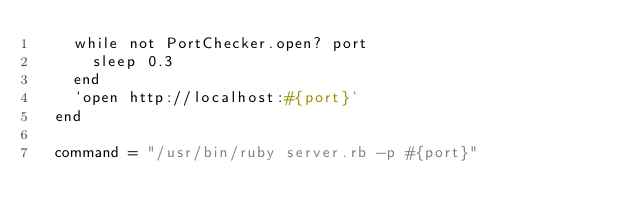Convert code to text. <code><loc_0><loc_0><loc_500><loc_500><_Ruby_>    while not PortChecker.open? port
      sleep 0.3
    end
    `open http://localhost:#{port}`
  end

  command = "/usr/bin/ruby server.rb -p #{port}"</code> 